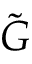<formula> <loc_0><loc_0><loc_500><loc_500>\tilde { G }</formula> 